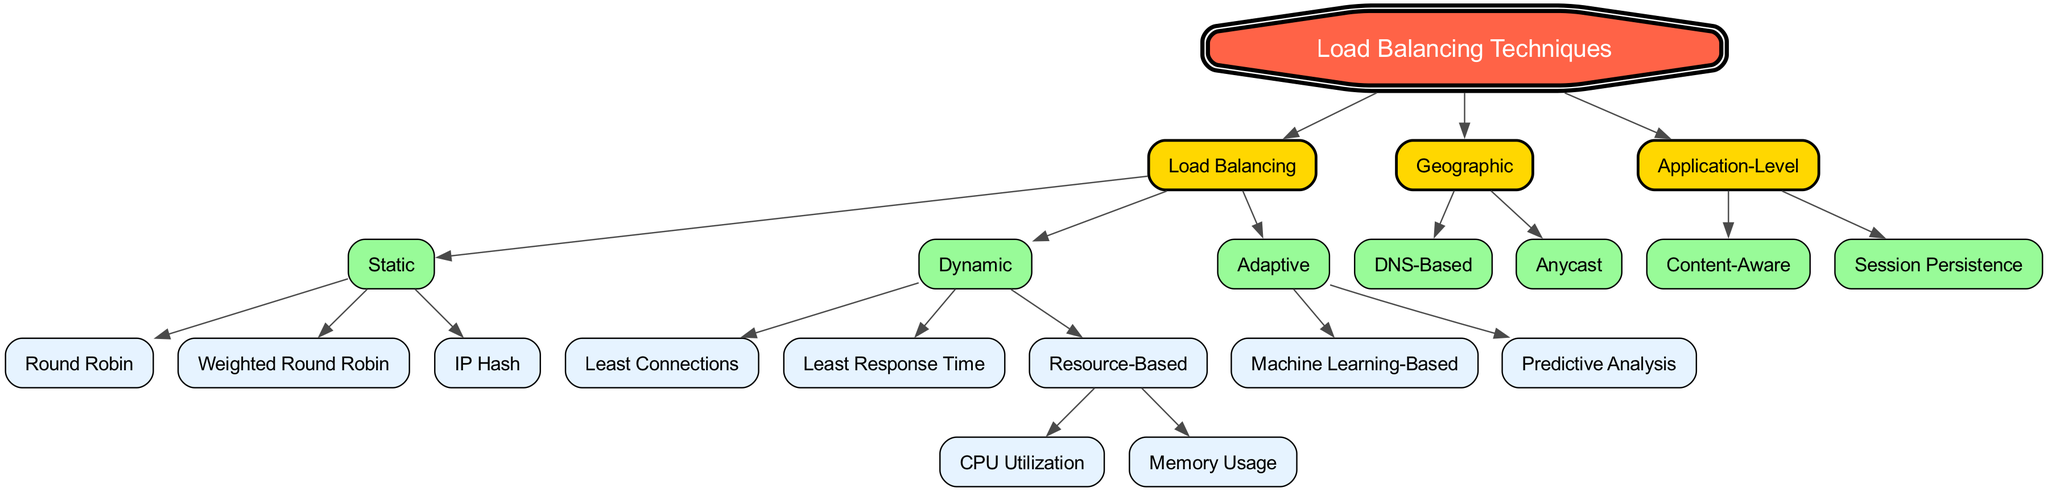What are the three major categories of load balancing techniques? The diagram shows the root node of "Load Balancing Techniques," which branches into three main categories: "Static," "Dynamic," and "Adaptive."
Answer: Static, Dynamic, Adaptive How many techniques are categorized under Static load balancing? Under the "Static" category, there are three techniques listed: "Round Robin," "Weighted Round Robin," and "IP Hash."
Answer: Three Which load balancing type involves the usage of Machine Learning? The diagram indicates that "Machine Learning-Based" is a technique found under the "Adaptive" category, which is denoted as a type of load balancing.
Answer: Machine Learning-Based What technique is considered resource-based in dynamic load balancing? The diagram specifies that "Resource-Based" under the "Dynamic" category includes further techniques: "CPU Utilization" and "Memory Usage." Thus, the resource-based technique referred to in the question is "Resource-Based."
Answer: Resource-Based How many total techniques are there in the Adaptive category? The "Adaptive" category contains two techniques: "Machine Learning-Based" and "Predictive Analysis," so the total count is two.
Answer: Two Which load balancing technique focuses on DNS functionality? The diagram shows that "DNS-Based" is a technique found under the "Geographic" category of load balancing, emphasizing its connection to DNS functionality.
Answer: DNS-Based What is the relationship between "Application-Level" and "Content-Aware"? The diagram depicts "Content-Aware" as a technique that belongs to the "Application-Level" category, illustrating a direct parent-child hierarchical relationship.
Answer: Application-Level Which method is concerned with maintaining session persistence? "Session Persistence" is explicitly mentioned as a technique under the "Application-Level" category, focusing on its particular application in load balancing.
Answer: Session Persistence Name one technique listed under Dynamic load balancing that relates to response time. The diagram indicates that "Least Response Time" is a technique categorized under the "Dynamic" load balancing techniques, directly relating to response time.
Answer: Least Response Time 